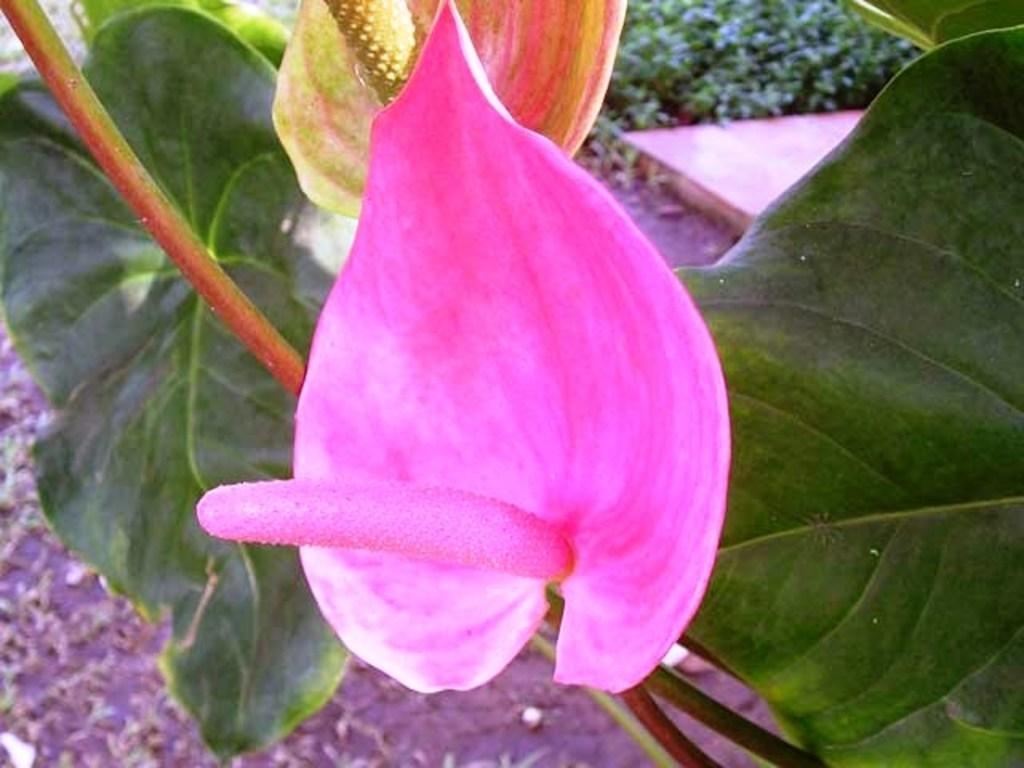What is the main subject of the image? The main subject of the image is a flower. Can you describe the flower's structure? The flower has a stem and leaves. How many eyes can be seen on the flower in the image? There are no eyes visible on the flower in the image, as flowers do not have eyes. 